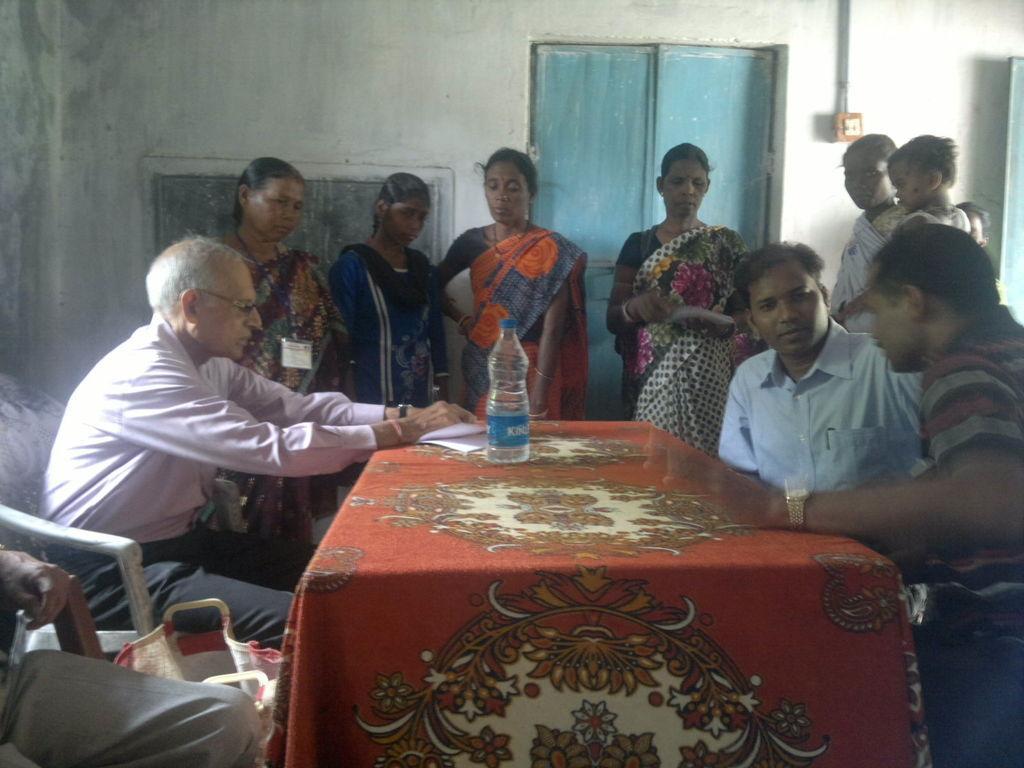Describe this image in one or two sentences. In this picture there are group of people, they are standing and sitting around the table, there is a bottle and papers on the table and there is a door at the center of the image. 